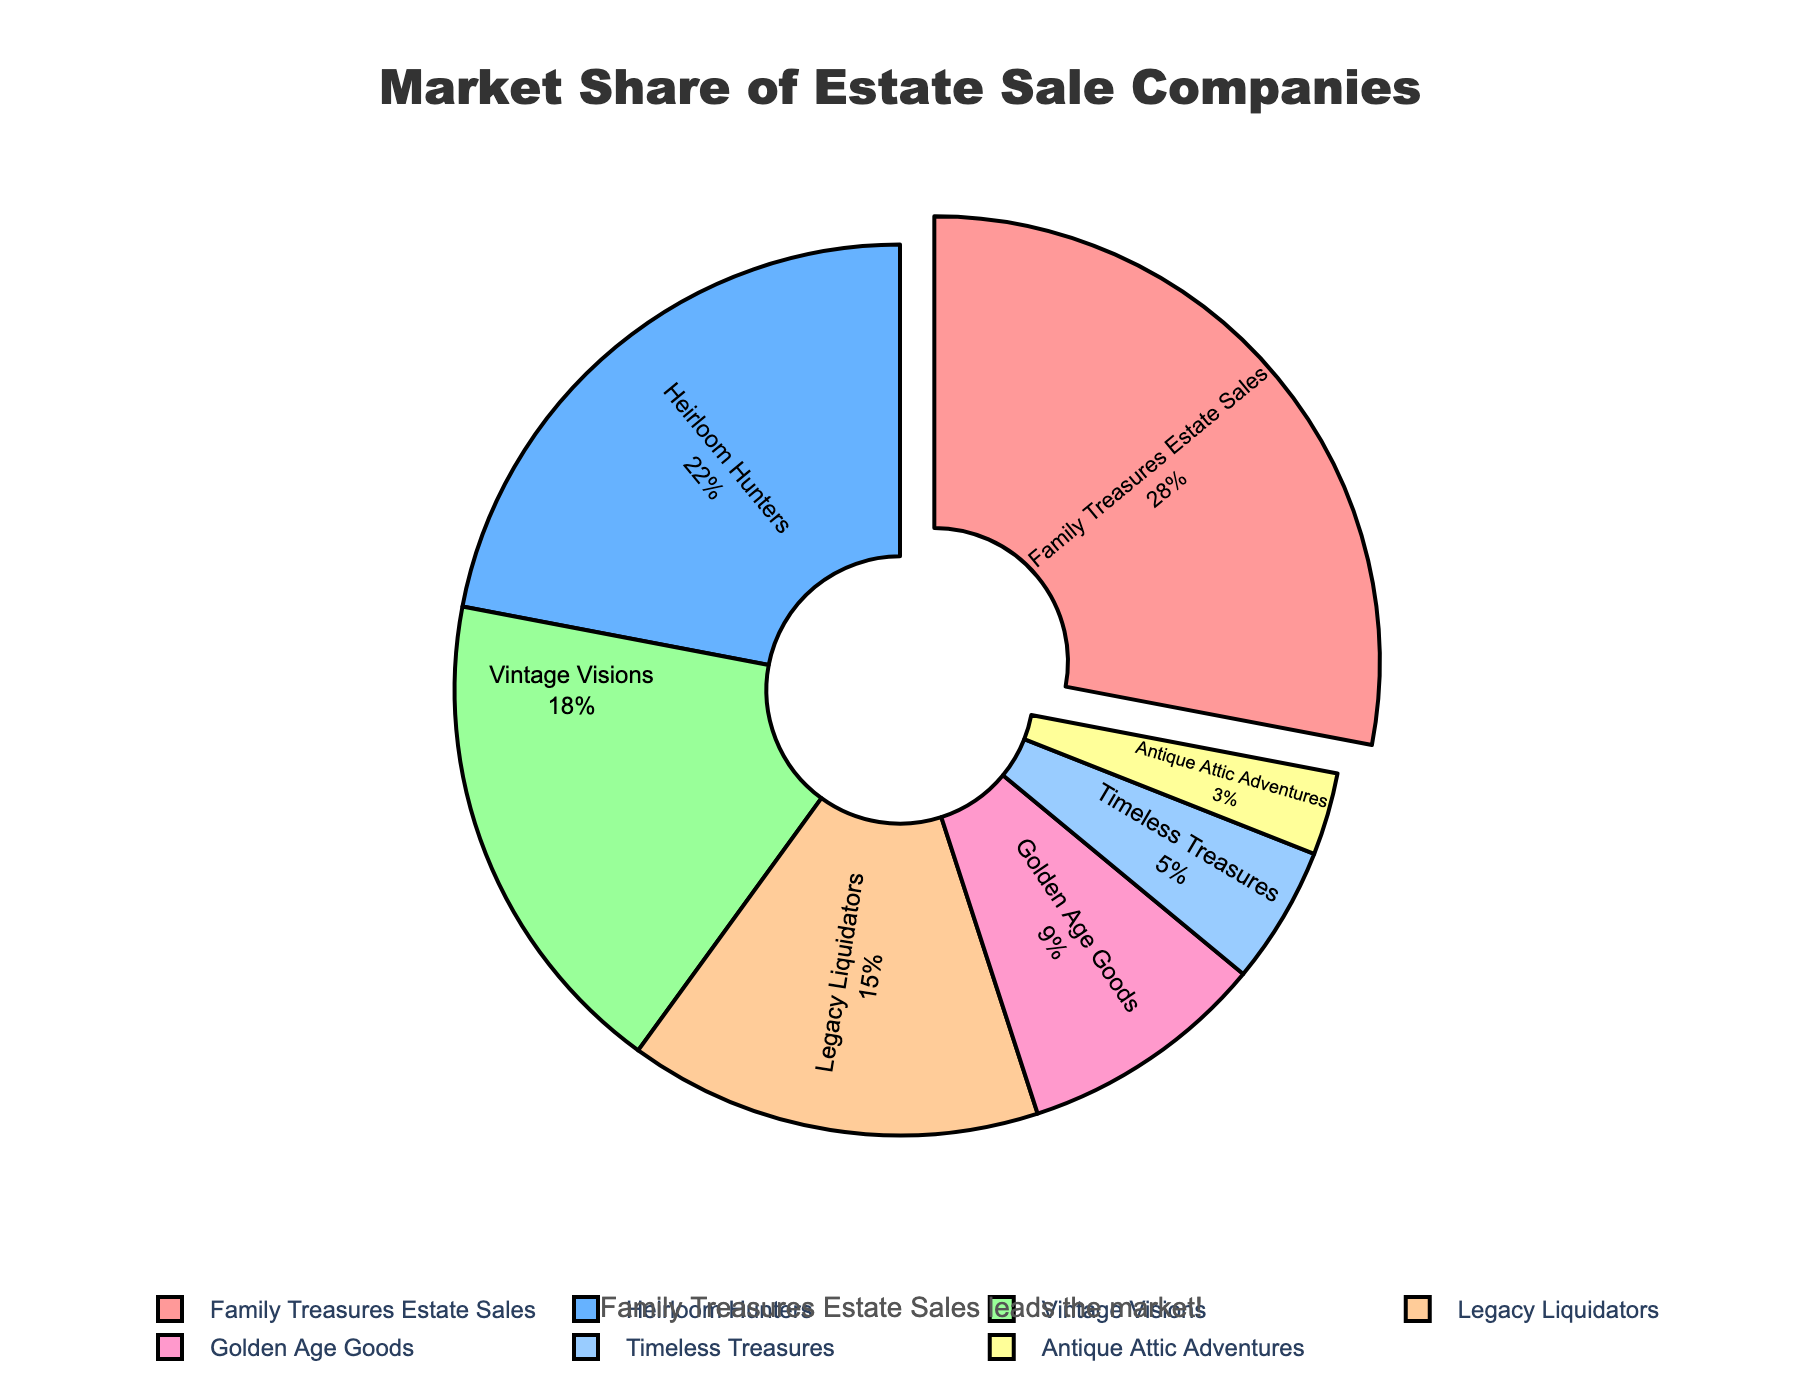what is the market share percentage of Family Treasures Estate Sales? The chart shows a pie section labeled "Family Treasures Estate Sales," and the market share percentage associated with this section is 28%.
Answer: 28% which company has the smallest market share? The chart indicates that the smallest pie segment belongs to "Antique Attic Adventures," which has a market share percentage of 3%.
Answer: Antique Attic Adventures how much greater is the market share of Family Treasures Estate Sales compared to Legacy Liquidators? The market share of Family Treasures Estate Sales is 28%, and the market share of Legacy Liquidators is 15%. Subtracting the two percentages, 28 - 15 gives us 13%.
Answer: 13% what is the combined market share percentage of Heirloom Hunters and Vintage Visions? Heirloom Hunters has a market share of 22%, and Vintage Visions has a market share of 18%. Adding these two percentages, 22 + 18 equals 40%.
Answer: 40% which company has a greater market share: Golden Age Goods or Timeless Treasures? Golden Age Goods has a market share of 9%, whereas Timeless Treasures has a market share of 5%. Since 9% is greater than 5%, Golden Age Goods has the greater market share.
Answer: Golden Age Goods what proportion of the total market share is held by companies other than Family Treasures Estate Sales? The total market share is 100%, and Family Treasures Estate Sales holds 28%. Subtracting 28 from 100 gives us 72%, which is the combined market share of the other companies.
Answer: 72% what is the average market share percentage of the companies with a market share of 10% or less? The companies with market shares of 10% or less are Golden Age Goods (9%), Timeless Treasures (5%), and Antique Attic Adventures (3%). Their total market share is 9 + 5 + 3 = 17%. Dividing 17% by the number of companies (3) gives an average of 17 / 3 ≈ 5.67%.
Answer: 5.67% which company holds the largest market share, and what color represents it in the chart? The company with the largest market share is Family Treasures Estate Sales, with 28%. The color representing this company in the chart is a shade of red.
Answer: Family Treasures Estate Sales, red how does the market share of Vintage Visions compare to the combined market share of Golden Age Goods and Timeless Treasures? Vintage Visions has a market share of 18%. Golden Age Goods has 9%, and Timeless Treasures has 5%. Their combined market share is 9 + 5 = 14%. So, Vintage Visions' market share (18%) is greater than the combined market share of the other two companies (14%).
Answer: Vintage Visions has a greater market share what is the difference in the market share percentage between Heirloom Hunters and Antique Attic Adventures? Heirloom Hunters has a market share of 22%, and Antique Attic Adventures has a market share of 3%. Subtracting the two percentages, 22 - 3 gives us 19%.
Answer: 19% 